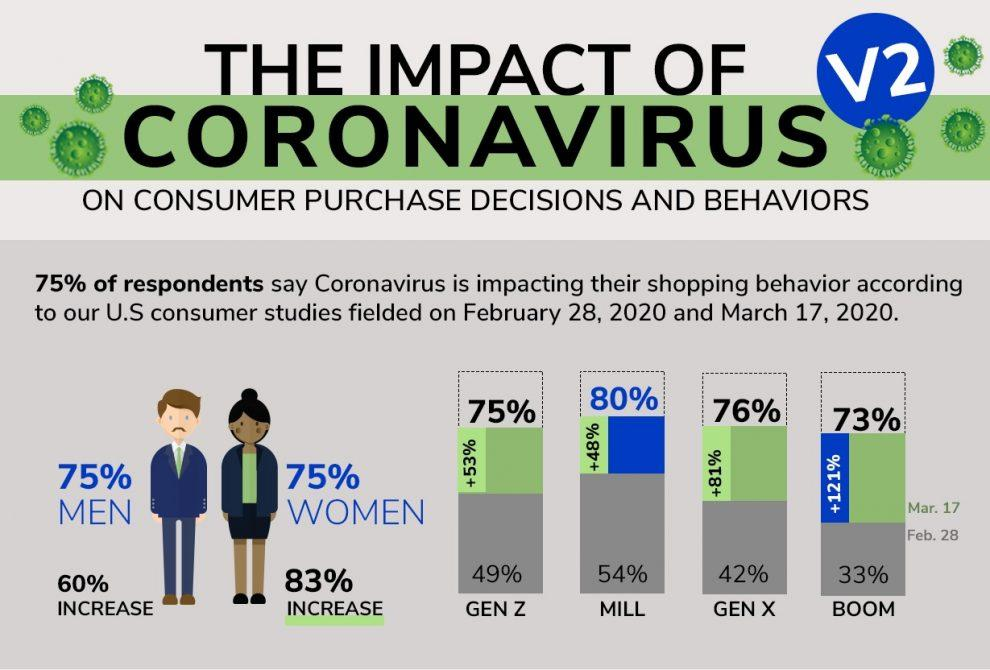Indicate a few pertinent items in this graphic. According to the survey, 25% of respondents disagree that the coronavirus has affected their shopping behavior. 